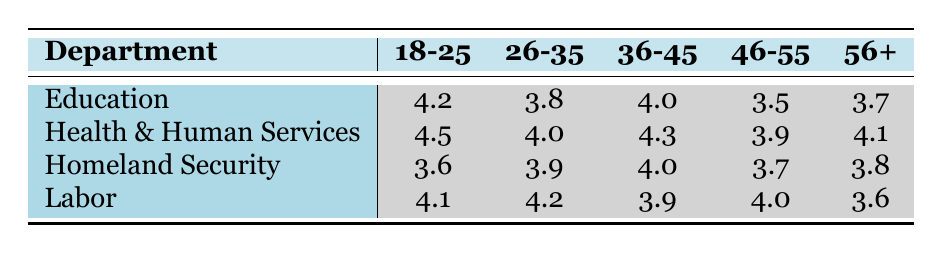What is the satisfaction rating for the Department of Education for the age group 36-45? The table shows that for the Department of Education, the satisfaction rating for the age group 36-45 is 4.0.
Answer: 4.0 Which age group has the highest satisfaction rating in the Department of Health and Human Services? The table indicates that the age group 18-25 in the Department of Health and Human Services has the highest satisfaction rating at 4.5.
Answer: 18-25 What is the average satisfaction rating for the 46-55 age group across all departments? To find the average for the 46-55 age group, we sum the ratings: 3.5 (Education) + 3.9 (Health and Human Services) + 3.7 (Homeland Security) + 4.0 (Labor) = 14.1. There are 4 ratings, so the average is 14.1 / 4 = 3.525.
Answer: 3.525 Is the satisfaction rating for the 26-35 age group in the Department of Labor higher than that in the Department of Homeland Security? The satisfaction rating for the 26-35 age group in Labor is 4.2, while in Homeland Security it is 3.9. Therefore, 4.2 is higher than 3.9, confirming that the statement is true.
Answer: Yes Which department has the lowest satisfaction rating for the age group 18-25, and what is that rating? Looking across the table, the Department of Homeland Security has the lowest rating for age group 18-25 at 3.6.
Answer: Department of Homeland Security, 3.6 